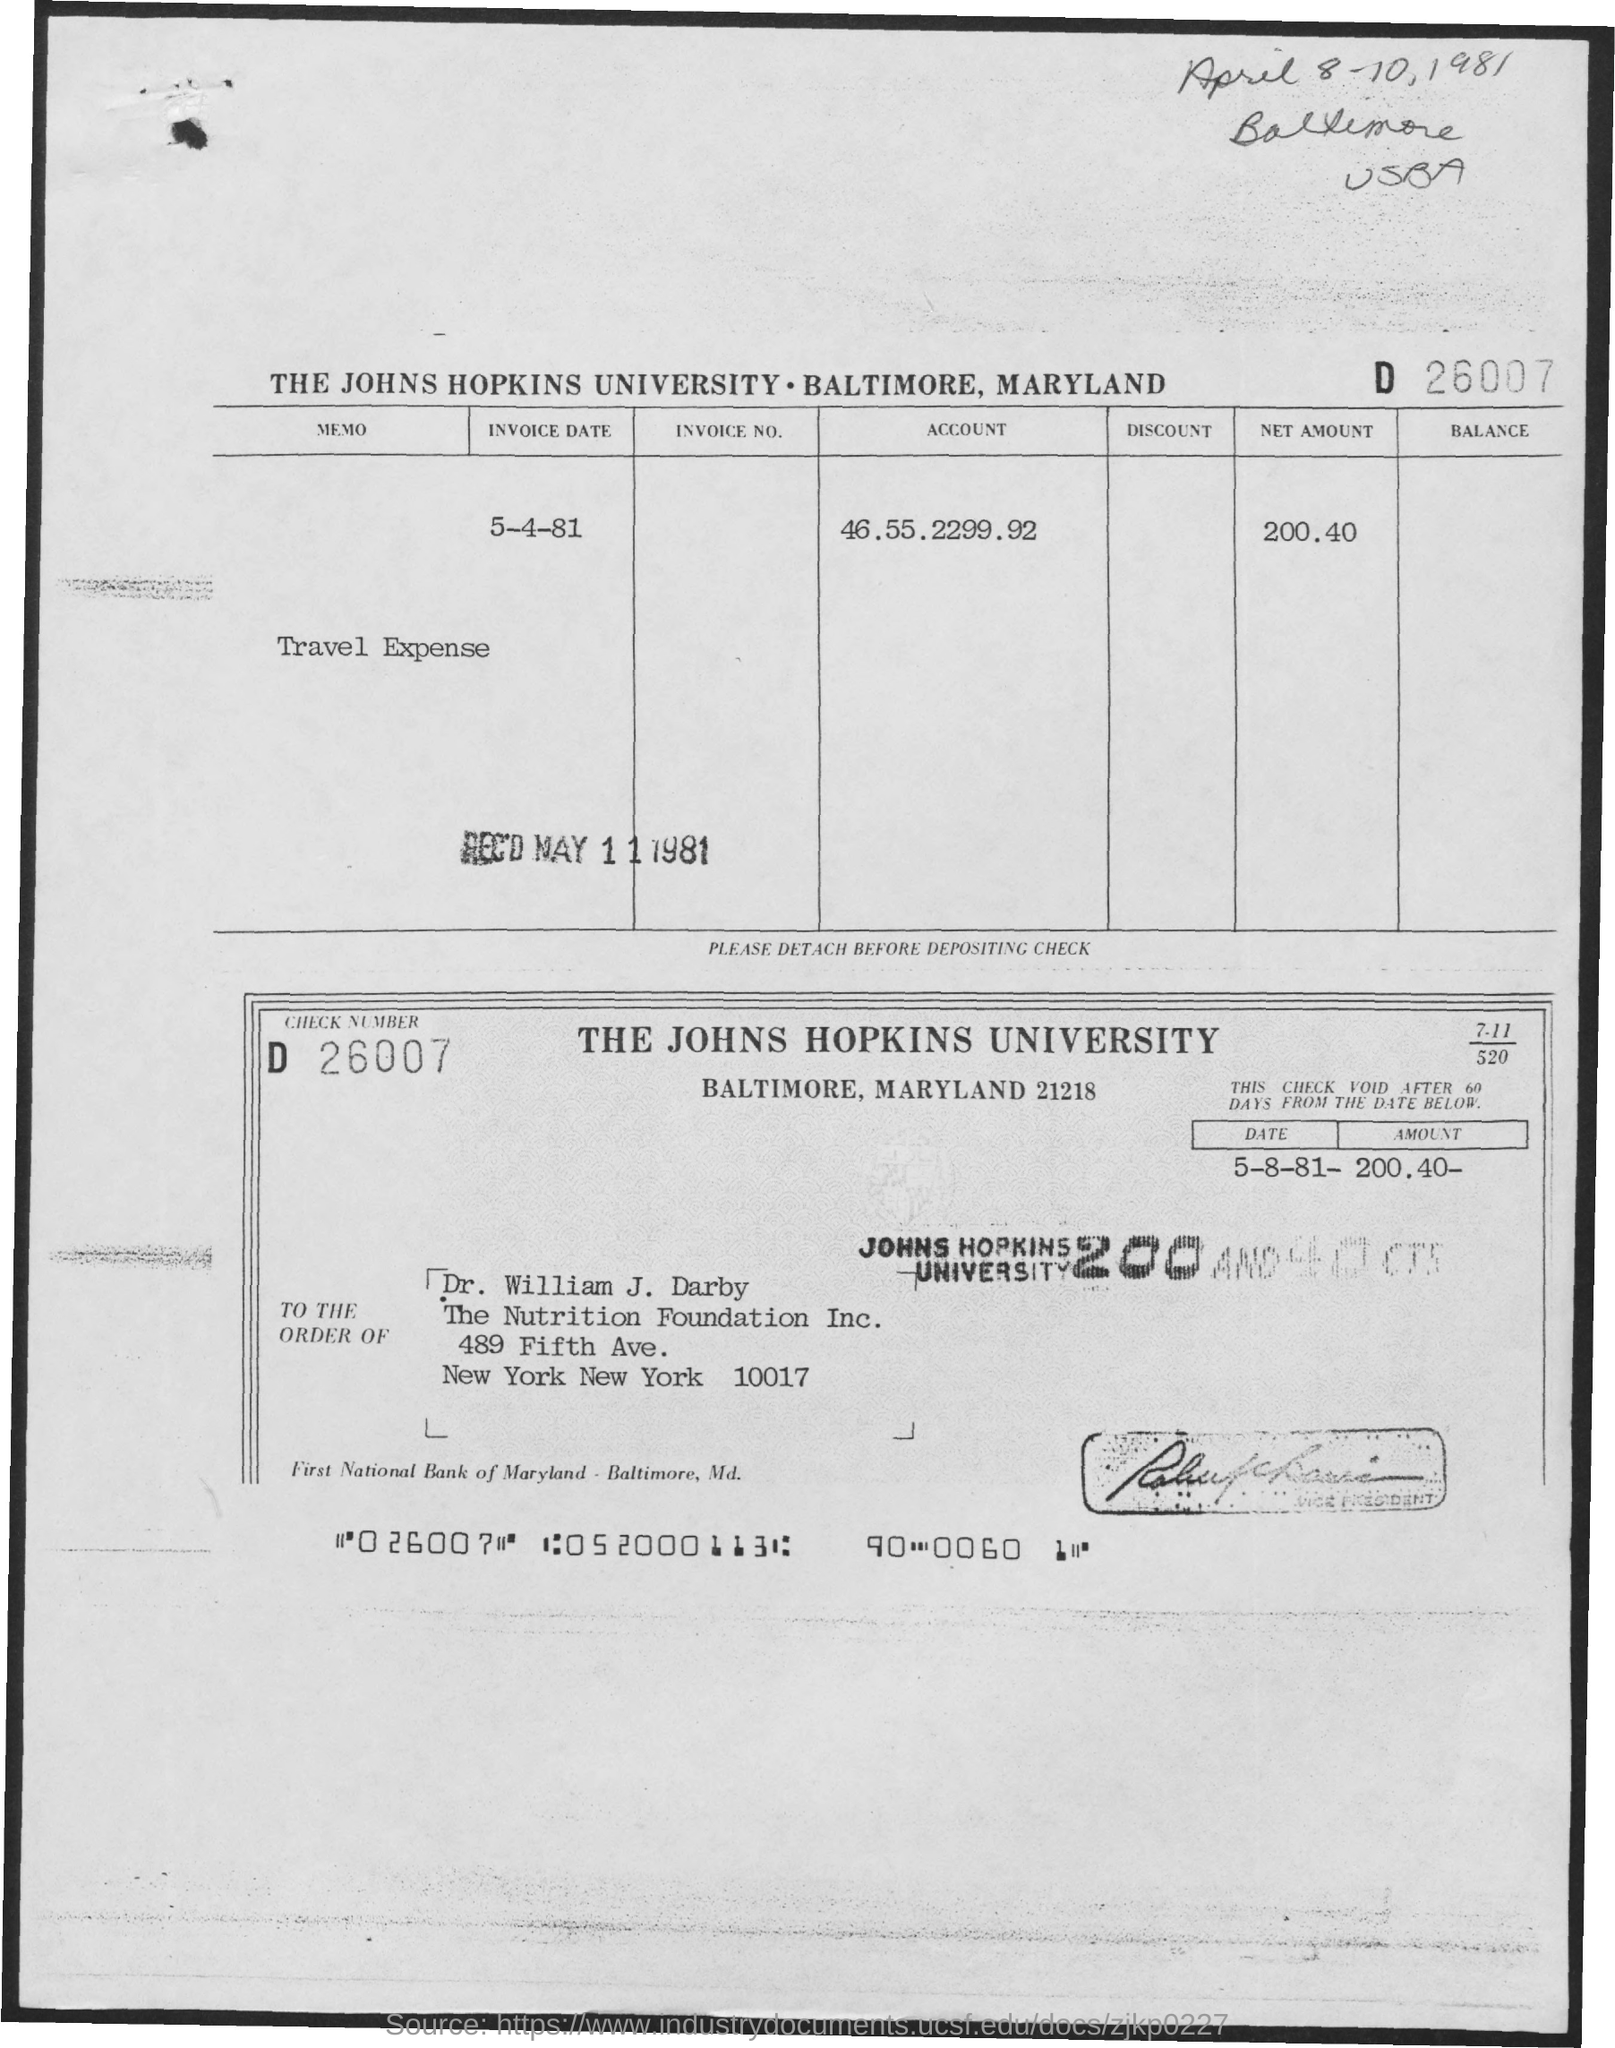Indicate a few pertinent items in this graphic. The amount is 200.40. The account number is 46.55.2299.92... The invoice date is May 4, 1981. 